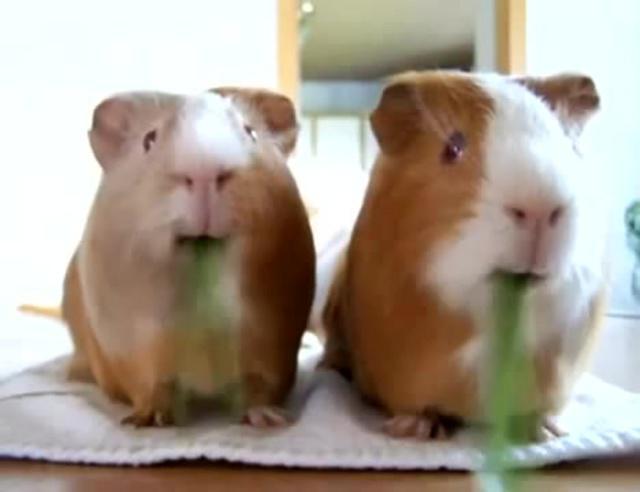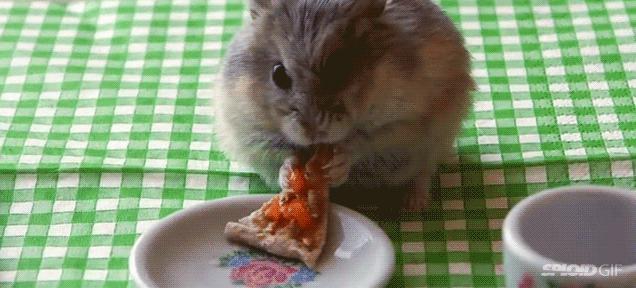The first image is the image on the left, the second image is the image on the right. For the images displayed, is the sentence "Two hamsters have something green in their mouths." factually correct? Answer yes or no. Yes. The first image is the image on the left, the second image is the image on the right. For the images shown, is this caption "One image shows two guinea pigs eating side by side." true? Answer yes or no. Yes. 